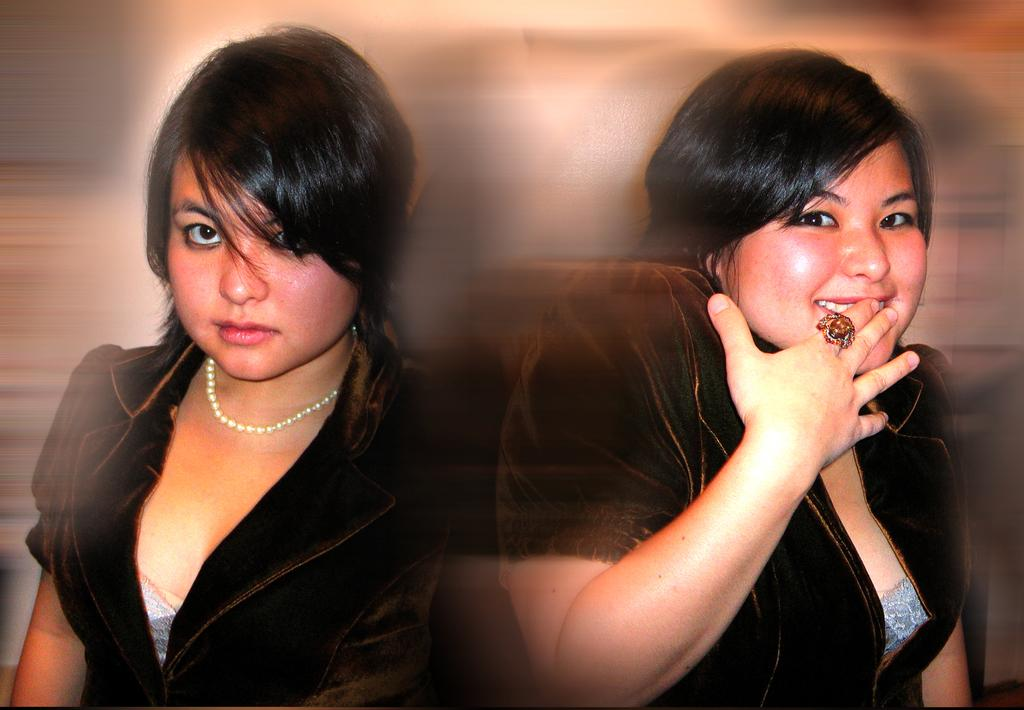How many people are in the image? There are two women in the image. Can you describe the background of the image? The background of the image is blurred. Is there any quicksand visible in the image? No, there is no quicksand present in the image. What type of pail can be seen being used by one of the women in the image? There is no pail visible in the image. 